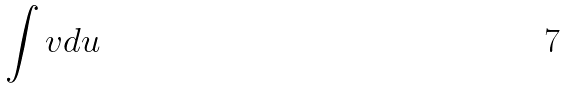<formula> <loc_0><loc_0><loc_500><loc_500>\int v d u</formula> 